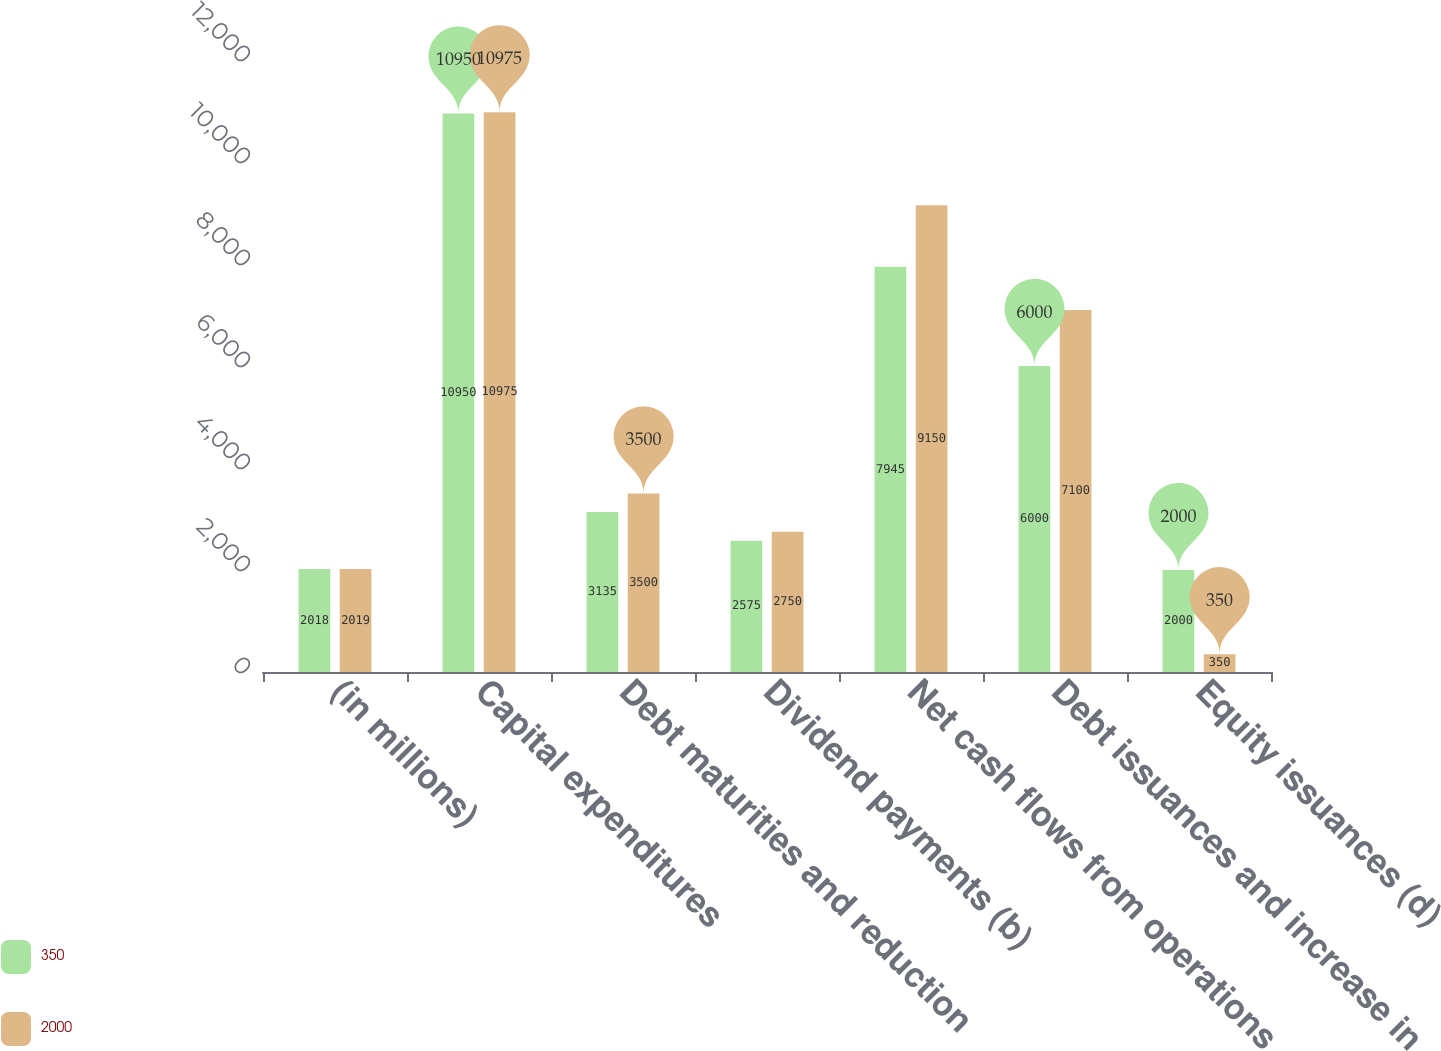<chart> <loc_0><loc_0><loc_500><loc_500><stacked_bar_chart><ecel><fcel>(in millions)<fcel>Capital expenditures<fcel>Debt maturities and reduction<fcel>Dividend payments (b)<fcel>Net cash flows from operations<fcel>Debt issuances and increase in<fcel>Equity issuances (d)<nl><fcel>350<fcel>2018<fcel>10950<fcel>3135<fcel>2575<fcel>7945<fcel>6000<fcel>2000<nl><fcel>2000<fcel>2019<fcel>10975<fcel>3500<fcel>2750<fcel>9150<fcel>7100<fcel>350<nl></chart> 